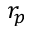<formula> <loc_0><loc_0><loc_500><loc_500>r _ { p }</formula> 